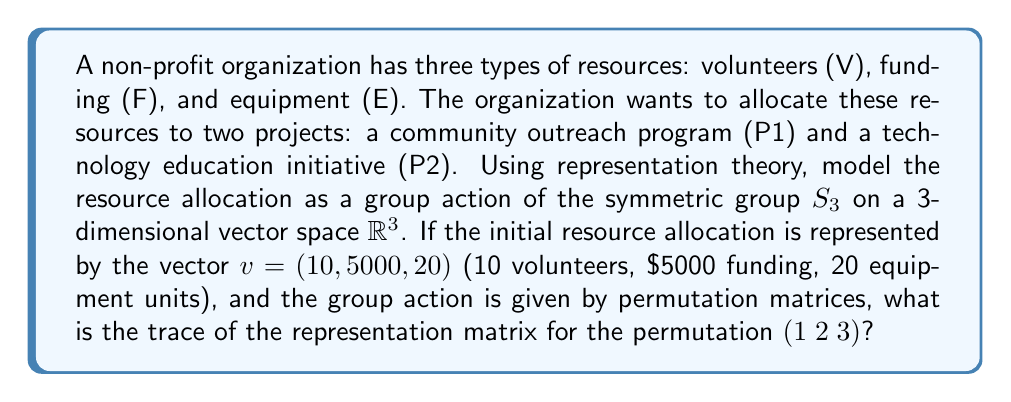Can you answer this question? Let's approach this step-by-step:

1) First, we need to understand what the representation looks like. We're using the symmetric group $S_3$ acting on $\mathbb{R}^3$ by permutation matrices.

2) The permutation $(1 2 3)$ corresponds to the cycle that sends 1 to 2, 2 to 3, and 3 back to 1.

3) The permutation matrix for $(1 2 3)$ is:

   $$\rho((1 2 3)) = \begin{pmatrix}
   0 & 0 & 1 \\
   1 & 0 & 0 \\
   0 & 1 & 0
   \end{pmatrix}$$

4) The trace of a matrix is the sum of its diagonal elements.

5) In this case, the diagonal elements are:
   - Top-left: 0
   - Middle: 0
   - Bottom-right: 0

6) Therefore, the trace of this matrix is:

   $$\text{Tr}(\rho((1 2 3))) = 0 + 0 + 0 = 0$$

Note: The initial vector $v = (10, 5000, 20)$ is not directly used in calculating the trace of the representation matrix. It's provided to give context to what the dimensions represent in this resource allocation problem.
Answer: $0$ 